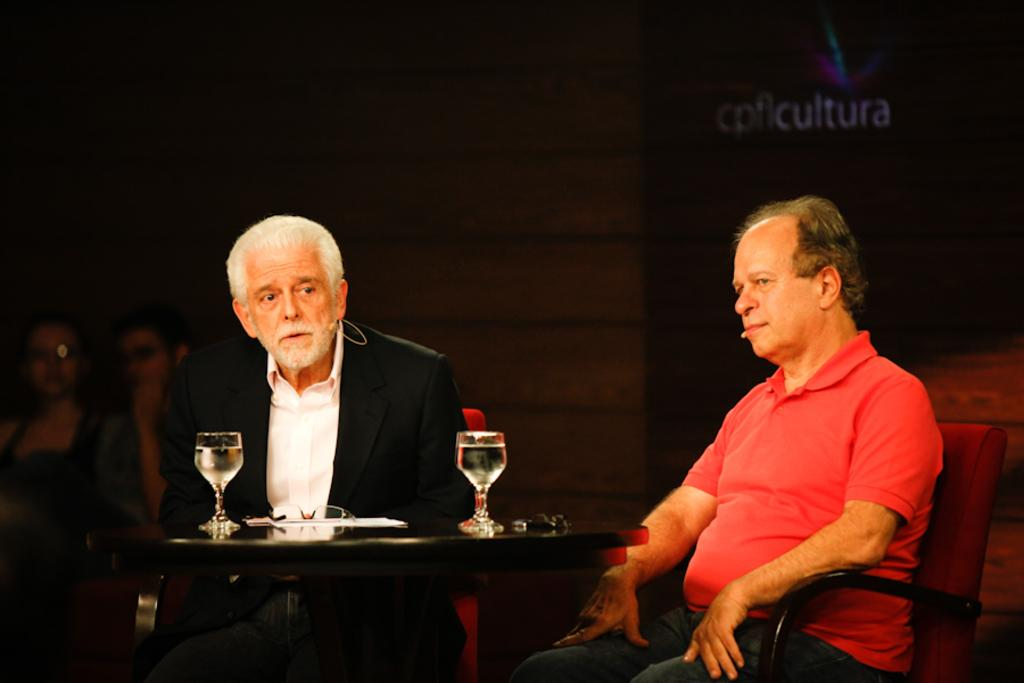How many people are sitting on the chair in the image? There are two men sitting on a chair in the image. What objects can be seen on the table in the image? There are two glasses on a table in the image. Can you describe the people sitting in the background? There are two persons sitting in the background in the image. What can be seen behind the people in the image? There is a wall visible in the background in the image. What type of connection can be seen between the two men's necks in the image? There is no visible connection between the two men's necks in the image. How many numbers are present in the image? The image does not contain any numbers. 